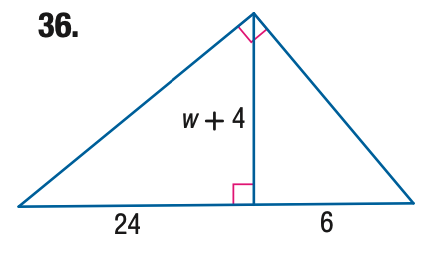Question: Find the value of the variable w.
Choices:
A. 4
B. 8
C. 12
D. 16
Answer with the letter. Answer: B 